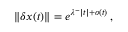<formula> <loc_0><loc_0><loc_500><loc_500>\| \delta x ( t ) \| = e ^ { \lambda ^ { - } | t | + o ( t ) } \, ,</formula> 